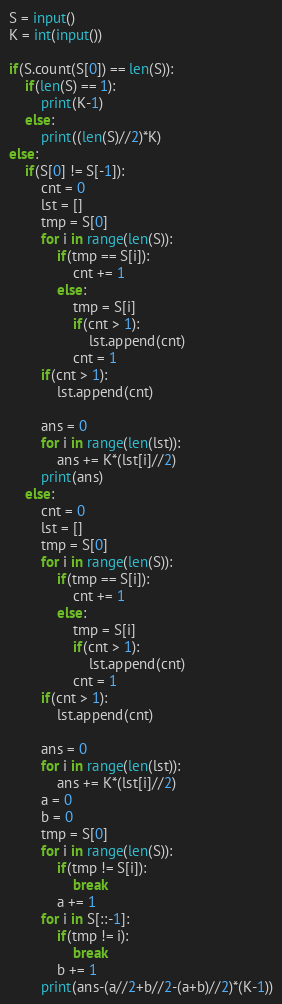Convert code to text. <code><loc_0><loc_0><loc_500><loc_500><_Python_>S = input()
K = int(input())

if(S.count(S[0]) == len(S)):
    if(len(S) == 1):
        print(K-1)
    else:
        print((len(S)//2)*K)
else:
    if(S[0] != S[-1]):
        cnt = 0
        lst = []
        tmp = S[0]
        for i in range(len(S)):
            if(tmp == S[i]):
                cnt += 1
            else:
                tmp = S[i]
                if(cnt > 1):
                    lst.append(cnt)
                cnt = 1   
        if(cnt > 1):
            lst.append(cnt)
        
        ans = 0
        for i in range(len(lst)):
            ans += K*(lst[i]//2)
        print(ans)
    else:
        cnt = 0
        lst = []
        tmp = S[0]
        for i in range(len(S)):
            if(tmp == S[i]):
                cnt += 1
            else:
                tmp = S[i]
                if(cnt > 1):
                    lst.append(cnt)
                cnt = 1
        if(cnt > 1):
            lst.append(cnt)
    
        ans = 0
        for i in range(len(lst)):
            ans += K*(lst[i]//2)
        a = 0
        b = 0
        tmp = S[0]
        for i in range(len(S)):
            if(tmp != S[i]):
                break
            a += 1
        for i in S[::-1]:
            if(tmp != i):
                break
            b += 1
        print(ans-(a//2+b//2-(a+b)//2)*(K-1))</code> 